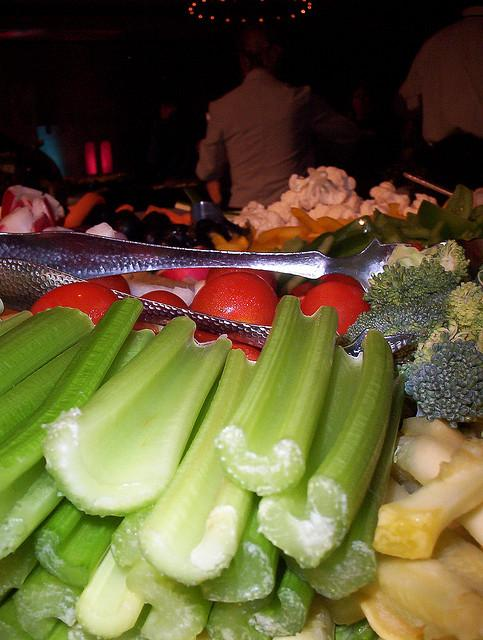What type of silver utensil sits atop the salad bar? tongs 